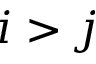Convert formula to latex. <formula><loc_0><loc_0><loc_500><loc_500>i > j</formula> 